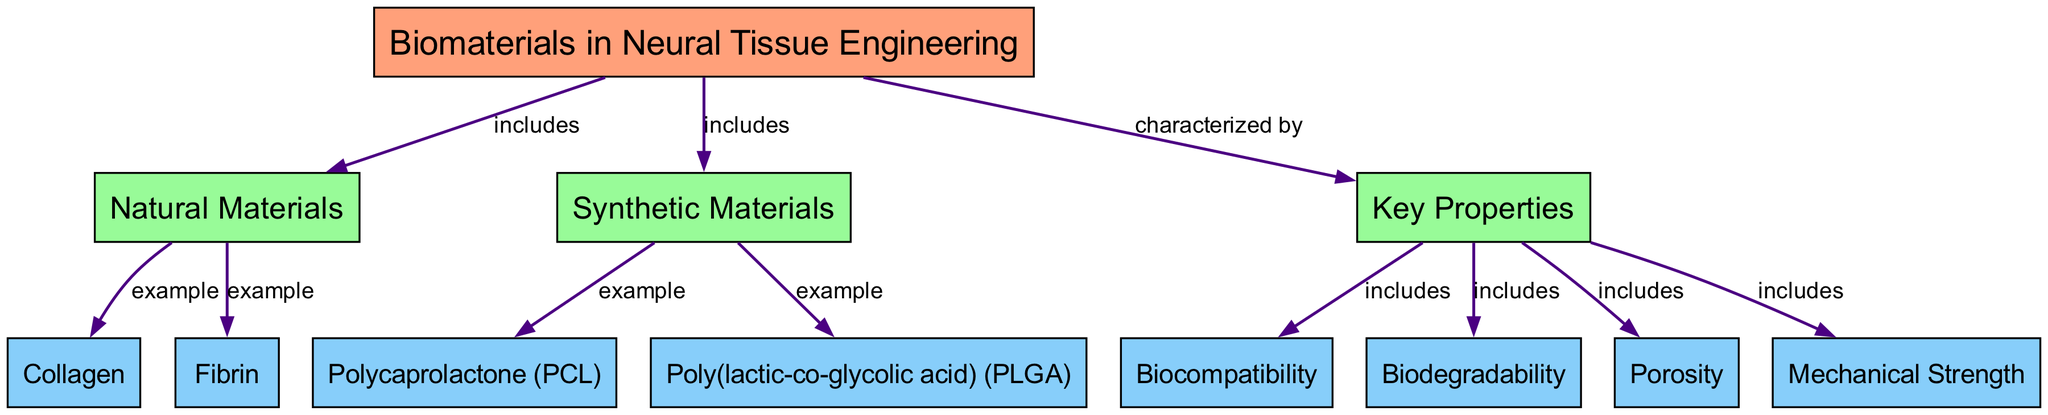What are the two main categories of biomaterials in neural tissue engineering? The diagram shows that biomaterials are categorized into two main groups: natural materials and synthetic materials. These categories are directly linked from the biomaterials node.
Answer: Natural materials and synthetic materials How many examples of natural materials are provided in the diagram? The diagram lists two examples under the natural materials node: collagen and fibrin. By counting these examples, we find that there are two.
Answer: 2 What are the key properties characterized by biomaterials? The properties node branches out to four key properties: biocompatibility, biodegradability, porosity, and mechanical strength, as indicated by the edges connecting them.
Answer: Biocompatibility, biodegradability, porosity, mechanical strength Which synthetic material is an example listed in the diagram? The diagram indicates that polycaprolactone (PCL) and poly(lactic-co-glycolic acid) (PLGA) are examples of synthetic materials under the synthetic node.
Answer: Polycaprolactone (PCL) or poly(lactic-co-glycolic acid) (PLGA) What relationship do the properties have with biocompatibility? The properties node includes biocompatibility as one of its main characteristics, which is directly connected by an edge labeled "includes" from properties to biocompatibility.
Answer: Includes Explain the relationship between natural materials and their examples. The diagram shows a direct connection from the natural materials node to its examples. Both collagen and fibrin are indicated as examples of natural materials, highlighting that they belong to this category.
Answer: Examples include collagen and fibrin What is the significance of porosity in the context of key properties of biomaterials? Porosity is categorized under key properties, implying that it is an important characteristic that impacts the function and effectiveness of biomaterials in neural tissue engineering, affecting nutrient transport and cell infiltration.
Answer: Important for nutrient transport and cell infiltration Which category includes both collagen and fibrin? As observed in the diagram, both collagen and fibrin are categorized under natural materials, indicating their classification as such within the context of biomaterials.
Answer: Natural materials 